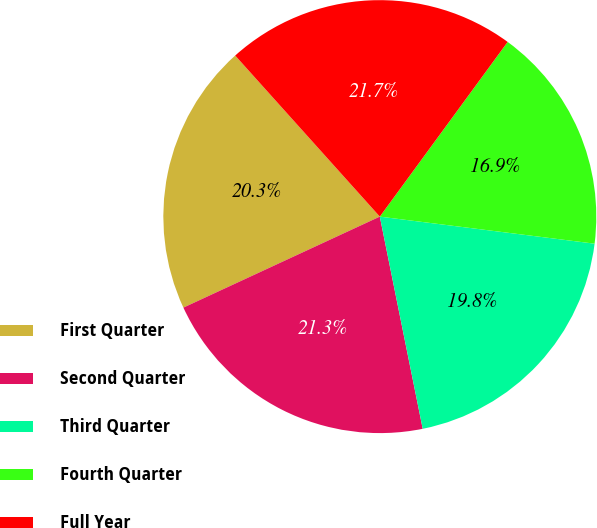Convert chart to OTSL. <chart><loc_0><loc_0><loc_500><loc_500><pie_chart><fcel>First Quarter<fcel>Second Quarter<fcel>Third Quarter<fcel>Fourth Quarter<fcel>Full Year<nl><fcel>20.26%<fcel>21.27%<fcel>19.83%<fcel>16.94%<fcel>21.7%<nl></chart> 